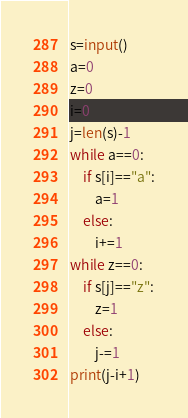<code> <loc_0><loc_0><loc_500><loc_500><_Python_>s=input()
a=0
z=0
i=0
j=len(s)-1
while a==0:
    if s[i]=="a":
        a=1
    else:
        i+=1
while z==0:
    if s[j]=="z":
        z=1
    else:
        j-=1
print(j-i+1)

</code> 